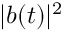<formula> <loc_0><loc_0><loc_500><loc_500>| b ( t ) | ^ { 2 }</formula> 